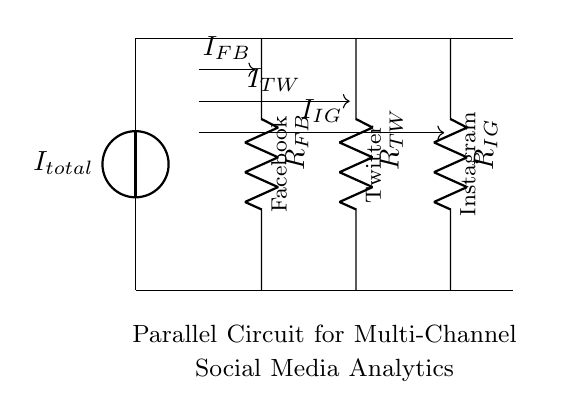What is the total current entering the circuit? The total current entering the circuit is represented by the current source labeled I total. In the diagram, it is indicated that this is the main current entering the parallel branches.
Answer: I total Which components are connected in parallel in the circuit? The components connected in parallel are the resistors labeled R FB for Facebook, R TW for Twitter, and R IG for Instagram. They are all connected between the same voltage source and share the same two nodes at the top and bottom.
Answer: R FB, R TW, R IG What is the current flowing through the Facebook analytics branch? The current flowing through the Facebook analytics branch is labeled as I FB in the diagram, showing the specific current that passes through R FB.
Answer: I FB How does the current divide among the three branches? The current divides among the branches based on the resistance values of each resistor. According to the current divider rule, the current flowing through each resistor is inversely proportional to its resistance; that is, higher resistance will have less current, and lower resistance will have more current.
Answer: By resistance values Which branch has the highest resistance? The branch with the highest resistance corresponds to the resistor with the highest value among R FB, R TW, and R IG; the exact value is not given, but visually assessing the lengths of the resistors while considering their labels could give that indication.
Answer: Highest R 